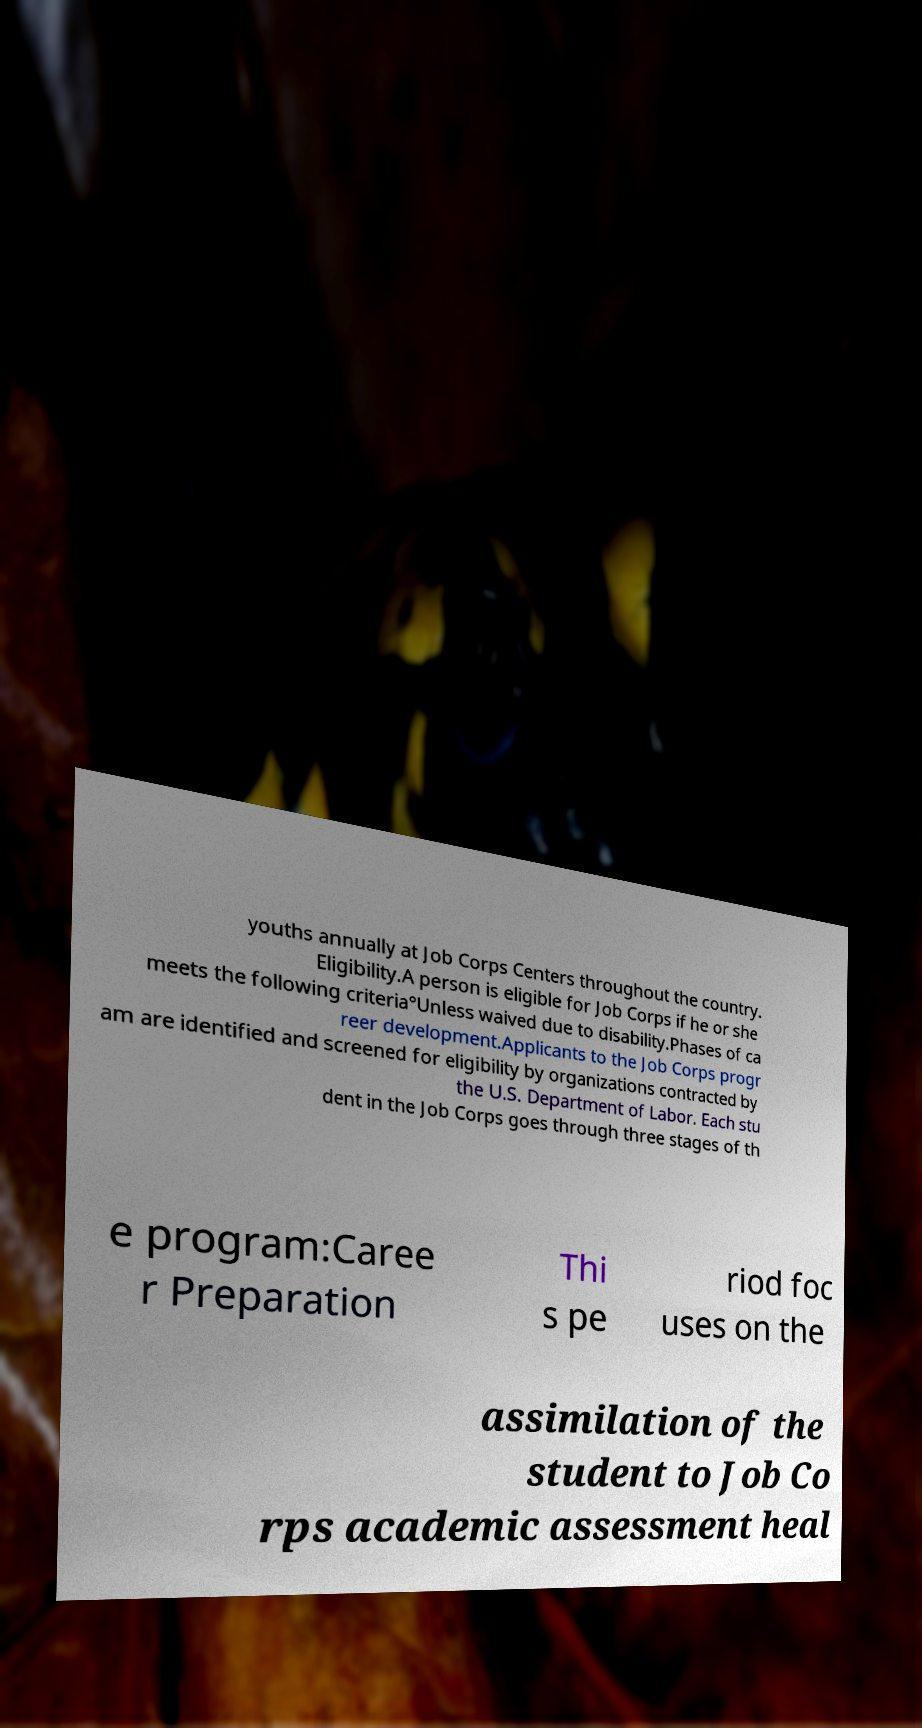Could you assist in decoding the text presented in this image and type it out clearly? youths annually at Job Corps Centers throughout the country. Eligibility.A person is eligible for Job Corps if he or she meets the following criteria°Unless waived due to disability.Phases of ca reer development.Applicants to the Job Corps progr am are identified and screened for eligibility by organizations contracted by the U.S. Department of Labor. Each stu dent in the Job Corps goes through three stages of th e program:Caree r Preparation Thi s pe riod foc uses on the assimilation of the student to Job Co rps academic assessment heal 